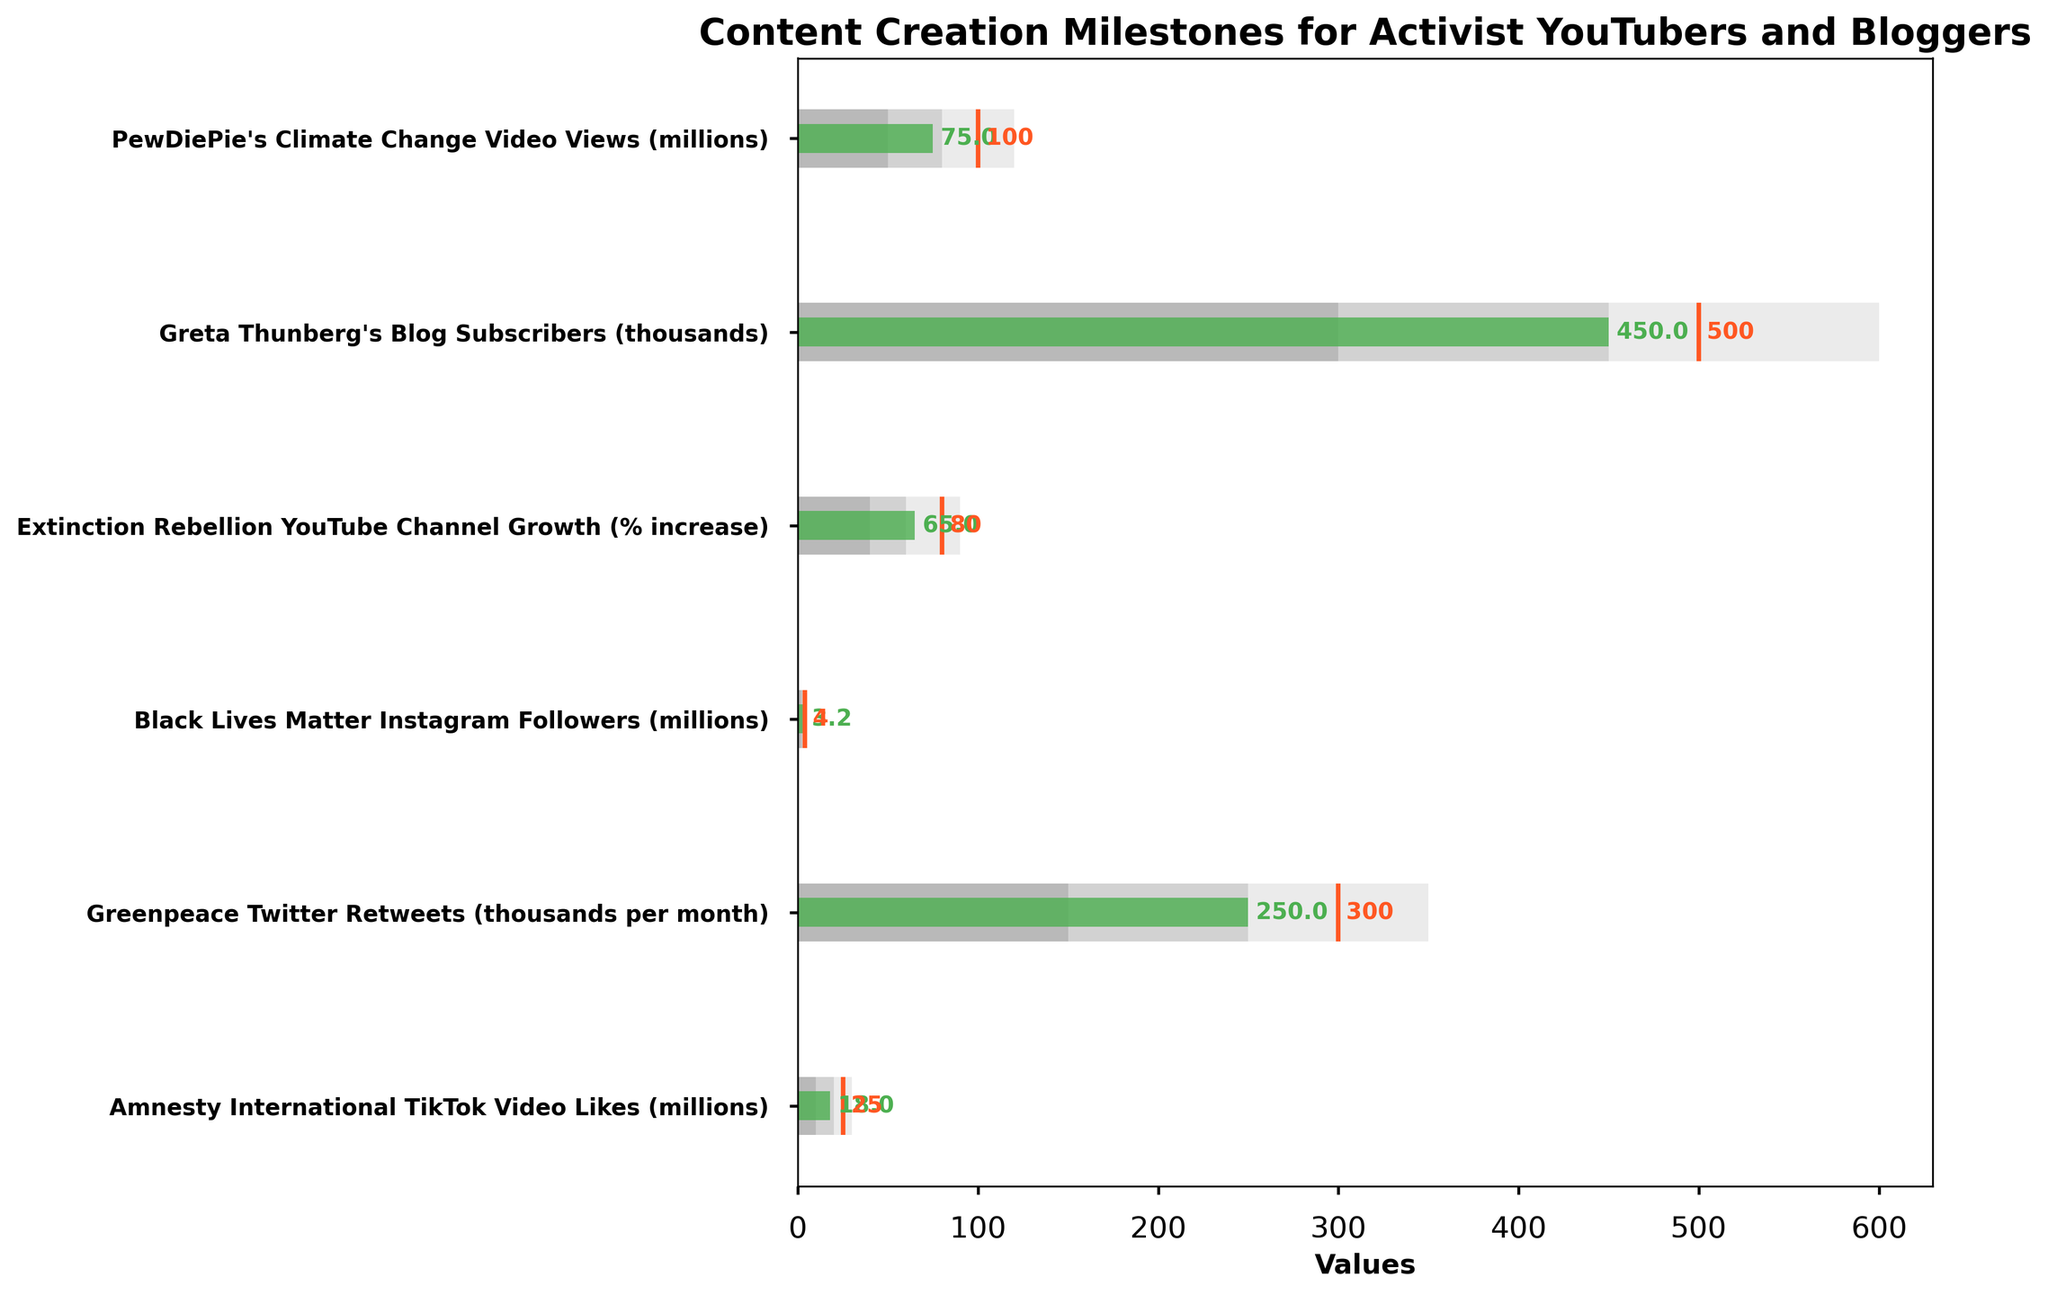Which activist has the highest actual value in their content creation milestone? Looking at the bars for actual values, Greta Thunberg's Blog Subscribers have the highest at 450,000.
Answer: Greta Thunberg's Blog Subscribers Which milestone has the furthest to go to reach its target? To find this, we calculate the difference between the target and the actual value for each milestone. PewDiePie's Climate Change Video Views have a target of 100 million and an actual of 75 million, making the difference 25 million - the greatest among the milestones.
Answer: PewDiePie's Climate Change Video Views What is the range of the Black Lives Matter Instagram followers' category with the highest density? Looking at the ranges for the Black Lives Matter Instagram followers, the third range (highest range) has the highest density and spans from 3 million to 5 million.
Answer: 3 million to 5 million How close is Extinction Rebellion YouTube Channel Growth to its target? The actual value for the Extinction Rebellion YouTube Channel Growth is 65%, and the target is 80%. To find how close it is, we find the difference 80% - 65% = 15%.
Answer: 15% Which milestone exceeded its first range? By identifying where the actual value surpasses the maximum of its first range, we see that PewDiePie's Climate Change Video Views (75 million, range up to 50 million) and Amnesty International TikTok Video Likes (18 million, range up to 10 million) both exceed their first ranges.
Answer: PewDiePie's Climate Change Video Views and Amnesty International TikTok Video Likes What color represents the target lines in the bullet chart? The color of the target lines can be seen as two vertical lines with the same color. They are represented in orange.
Answer: Orange What is the difference between the target and the actual value of Greenpeace Twitter Retweets? The target for Greenpeace Twitter Retweets is 300,000, and the actual value is 250,000. The difference is 300,000 - 250,000 = 50,000.
Answer: 50,000 Compare the actual values of Extinction Rebellion YouTube Channel Growth and Black Lives Matter Instagram Followers. Which one is higher? As per the chart, Extinction Rebellion YouTube Channel Growth has an actual value of 65% while Black Lives Matter Instagram Followers have an actual value of 3.2 million. Hence, Black Lives Matter Instagram Followers have the higher value.
Answer: Black Lives Matter Instagram Followers How does Greta Thunberg's Blog Subscribers actual value compare to its third range? The third range for Greta Thunberg's Blog Subscribers is from 450,000 to 600,000. Greta's Blog Subscribers have an actual value of 450,000, making them equal to the lower limit of the third range.
Answer: Equal to the lower limit of the third range 